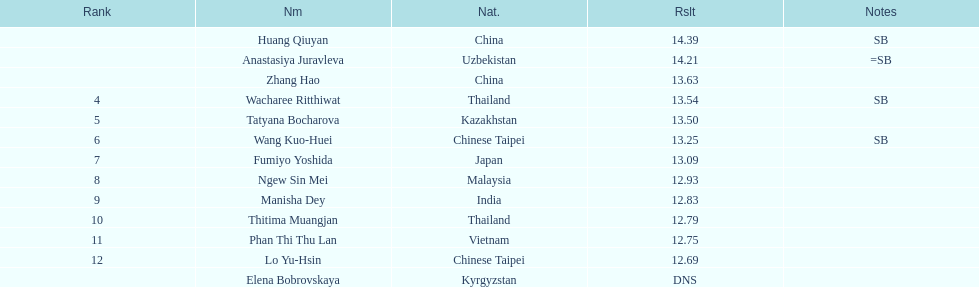Which country had the most competitors ranked in the top three in the event? China. 